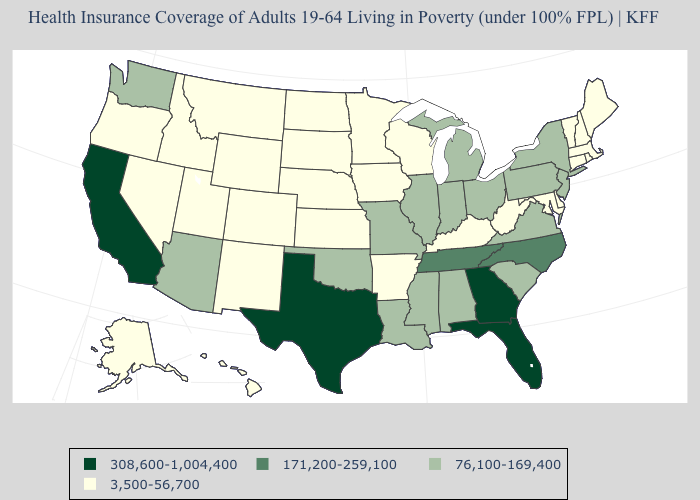Name the states that have a value in the range 76,100-169,400?
Concise answer only. Alabama, Arizona, Illinois, Indiana, Louisiana, Michigan, Mississippi, Missouri, New Jersey, New York, Ohio, Oklahoma, Pennsylvania, South Carolina, Virginia, Washington. Name the states that have a value in the range 76,100-169,400?
Write a very short answer. Alabama, Arizona, Illinois, Indiana, Louisiana, Michigan, Mississippi, Missouri, New Jersey, New York, Ohio, Oklahoma, Pennsylvania, South Carolina, Virginia, Washington. What is the value of New York?
Give a very brief answer. 76,100-169,400. Does South Carolina have the highest value in the USA?
Be succinct. No. Name the states that have a value in the range 171,200-259,100?
Concise answer only. North Carolina, Tennessee. Which states hav the highest value in the South?
Quick response, please. Florida, Georgia, Texas. Does Washington have the lowest value in the USA?
Answer briefly. No. What is the lowest value in the West?
Short answer required. 3,500-56,700. Name the states that have a value in the range 171,200-259,100?
Keep it brief. North Carolina, Tennessee. What is the highest value in the MidWest ?
Quick response, please. 76,100-169,400. Does Michigan have the highest value in the MidWest?
Give a very brief answer. Yes. How many symbols are there in the legend?
Be succinct. 4. Name the states that have a value in the range 3,500-56,700?
Keep it brief. Alaska, Arkansas, Colorado, Connecticut, Delaware, Hawaii, Idaho, Iowa, Kansas, Kentucky, Maine, Maryland, Massachusetts, Minnesota, Montana, Nebraska, Nevada, New Hampshire, New Mexico, North Dakota, Oregon, Rhode Island, South Dakota, Utah, Vermont, West Virginia, Wisconsin, Wyoming. Name the states that have a value in the range 76,100-169,400?
Quick response, please. Alabama, Arizona, Illinois, Indiana, Louisiana, Michigan, Mississippi, Missouri, New Jersey, New York, Ohio, Oklahoma, Pennsylvania, South Carolina, Virginia, Washington. Which states hav the highest value in the Northeast?
Keep it brief. New Jersey, New York, Pennsylvania. 